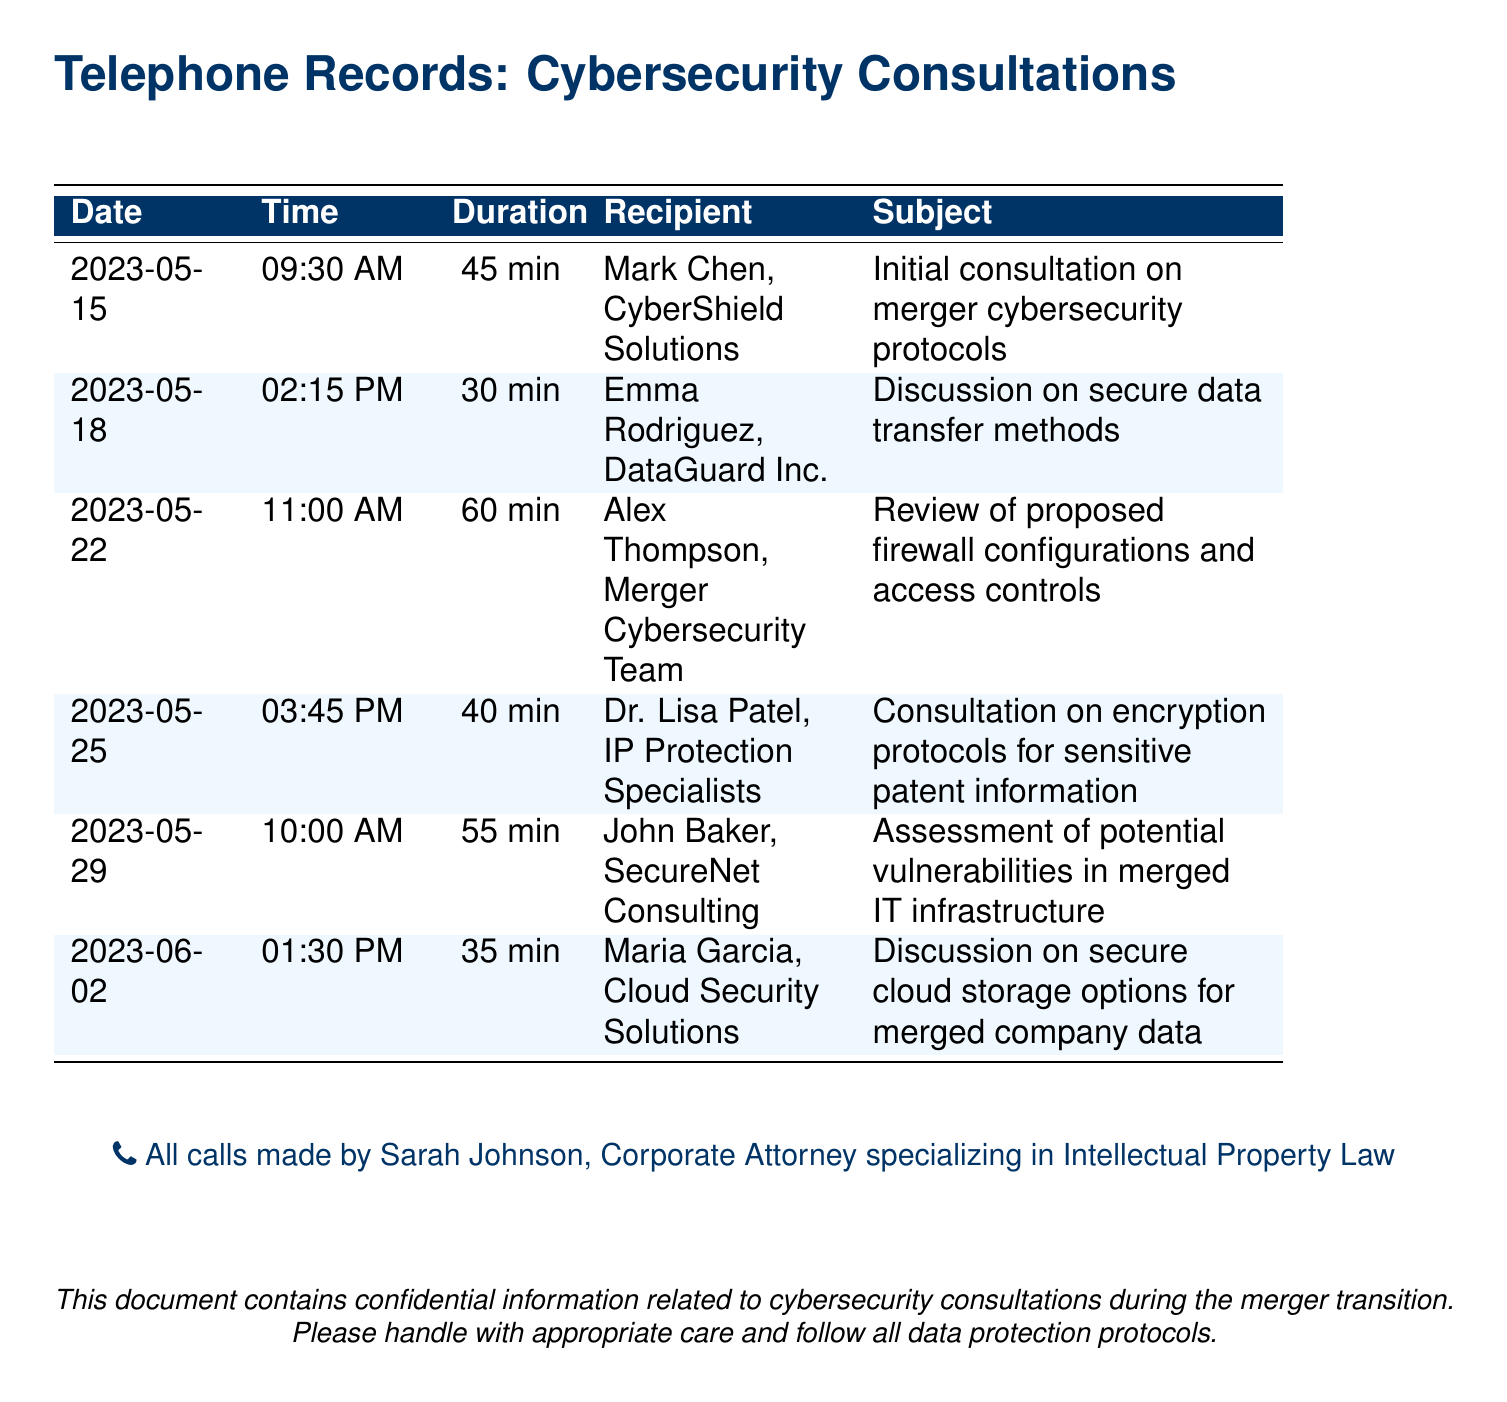What is the date of the first consultation? The first consultation occurred on May 15, 2023, according to the date column.
Answer: May 15, 2023 How long was the consultation with Alex Thompson? The consultation with Alex Thompson lasted for 60 minutes, as indicated in the duration column.
Answer: 60 min Who is the recipient of the call on May 25? The recipient of the call on May 25 is Dr. Lisa Patel as noted in the entry.
Answer: Dr. Lisa Patel What subject was discussed on June 2? The subject discussed on June 2 was secure cloud storage options, referencing the subject column for that date.
Answer: Secure cloud storage options How many consultants were involved in the calls? The document lists a total of five different cybersecurity consultants, which can be counted in the recipient column.
Answer: 5 Which company was consulted for encryption protocols? The document indicates that Dr. Lisa Patel from IP Protection Specialists was consulted regarding encryption protocols.
Answer: IP Protection Specialists What was the call duration for the consultation with John Baker? The call with John Baker lasted for 55 minutes, as shown in the duration column.
Answer: 55 min What is the primary purpose of these telephone records? The primary purpose is related to cybersecurity consultations during the merger transition, as stated in the document.
Answer: Cybersecurity consultations Who made all the calls in the document? All calls were made by Sarah Johnson, as stated in the footer of the document.
Answer: Sarah Johnson 